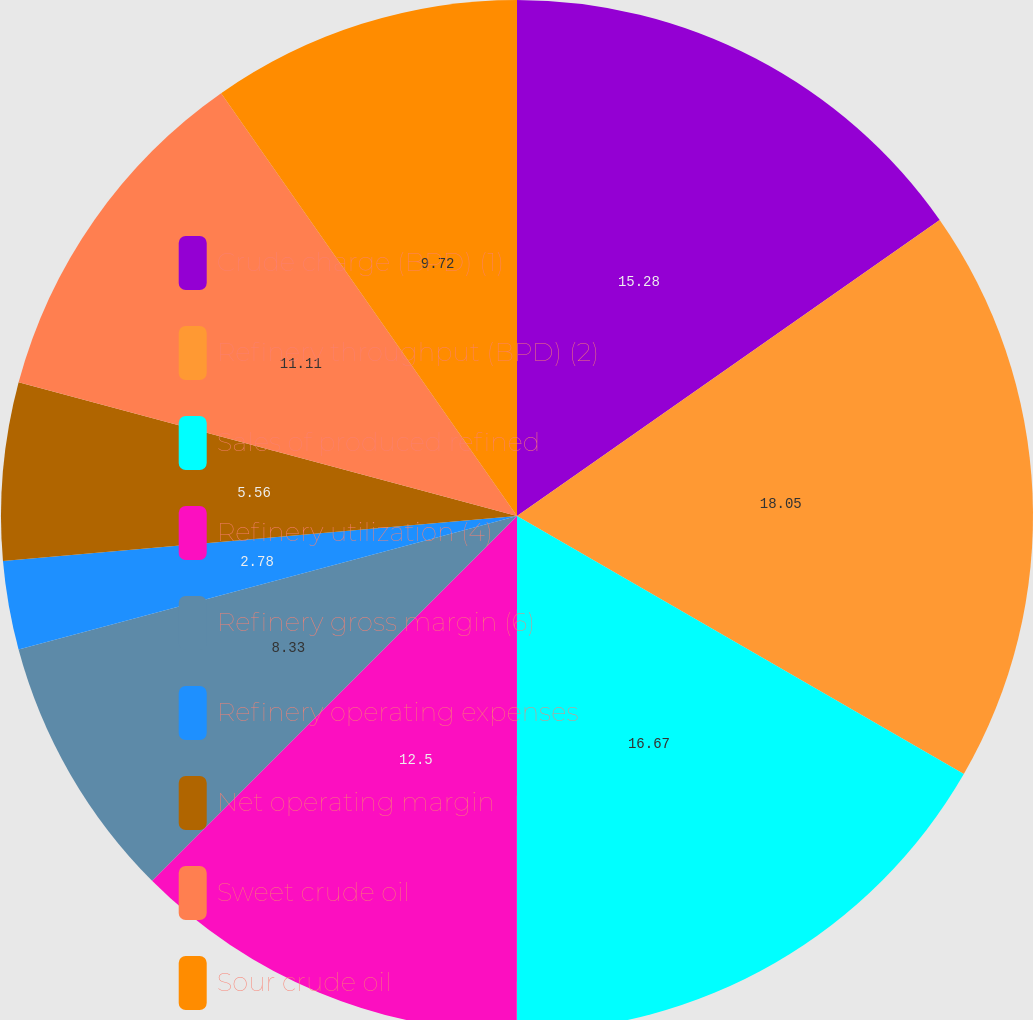Convert chart to OTSL. <chart><loc_0><loc_0><loc_500><loc_500><pie_chart><fcel>Crude charge (BPD) (1)<fcel>Refinery throughput (BPD) (2)<fcel>Sales of produced refined<fcel>Refinery utilization (4)<fcel>Refinery gross margin (6)<fcel>Refinery operating expenses<fcel>Net operating margin<fcel>Sweet crude oil<fcel>Sour crude oil<nl><fcel>15.28%<fcel>18.06%<fcel>16.67%<fcel>12.5%<fcel>8.33%<fcel>2.78%<fcel>5.56%<fcel>11.11%<fcel>9.72%<nl></chart> 